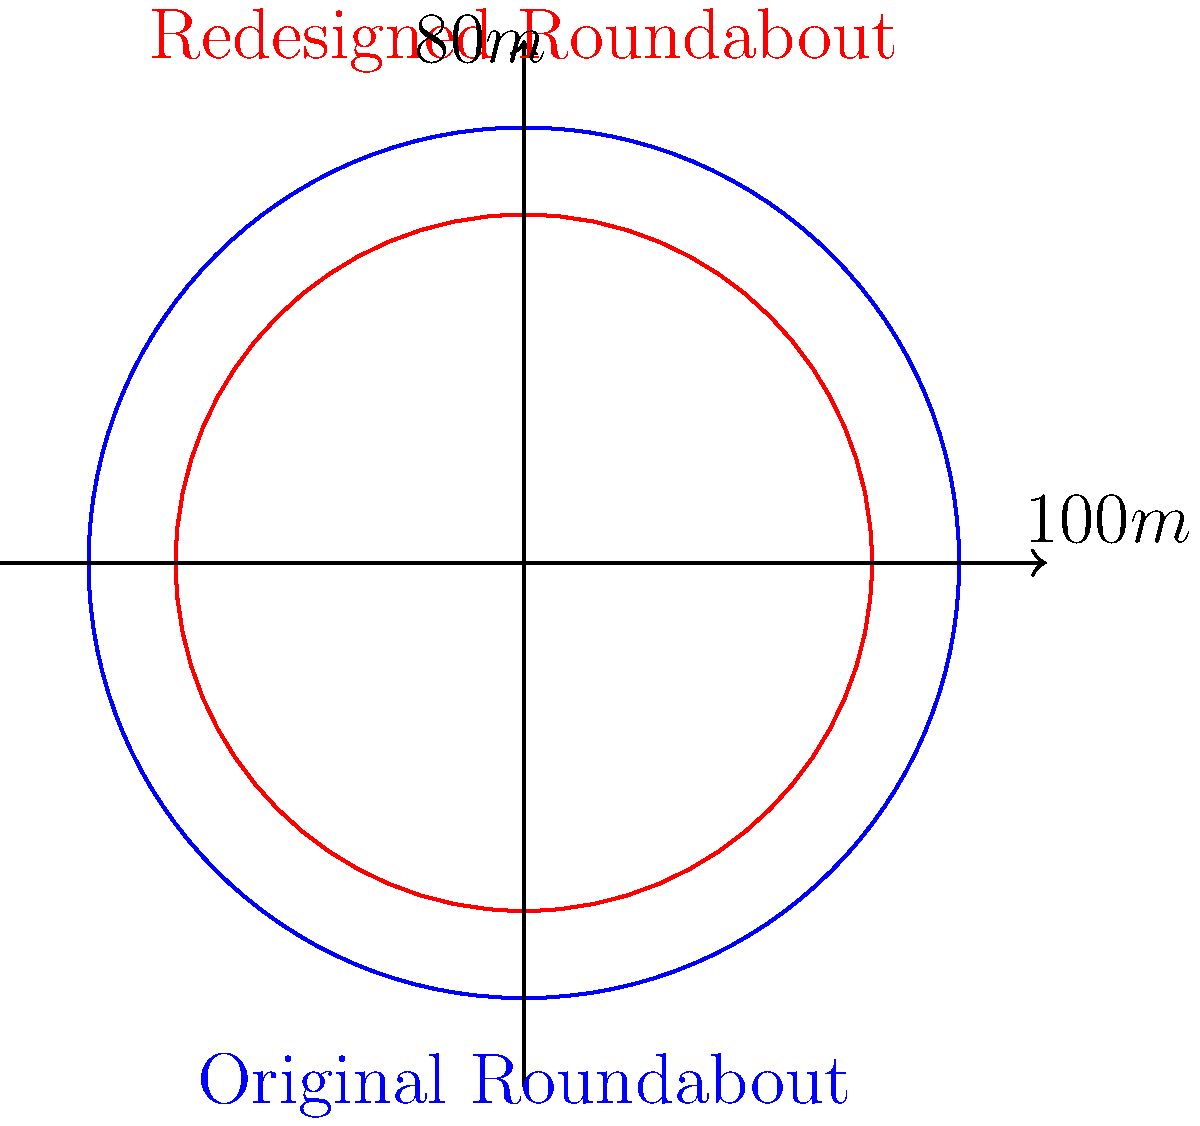A city planner is redesigning a circular roundabout to improve traffic flow. The original roundabout has a diameter of 100 meters. To increase efficiency, the planner proposes reducing the roundabout's area by 36%. What will be the new diameter of the redesigned roundabout? Round your answer to the nearest meter. Let's approach this step-by-step:

1) First, let's calculate the area of the original roundabout:
   Radius = Diameter / 2 = 100 / 2 = 50 meters
   Area = $\pi r^2$ = $\pi (50)^2$ = $2500\pi$ square meters

2) The new area will be 64% of the original area (100% - 36% = 64%):
   New Area = $0.64 * 2500\pi$ = $1600\pi$ square meters

3) Now, let's find the radius of the new roundabout:
   $1600\pi = \pi r^2$
   $1600 = r^2$
   $r = \sqrt{1600} = 40$ meters

4) The diameter is twice the radius:
   New Diameter = $2 * 40 = 80$ meters

Therefore, the new diameter of the redesigned roundabout will be 80 meters.
Answer: 80 meters 